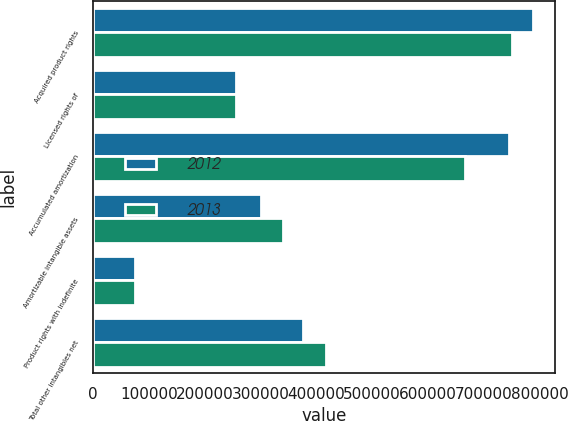Convert chart to OTSL. <chart><loc_0><loc_0><loc_500><loc_500><stacked_bar_chart><ecel><fcel>Acquired product rights<fcel>Licensed rights of<fcel>Accumulated amortization<fcel>Amortizable intangible assets<fcel>Product rights with indefinite<fcel>Total other intangibles net<nl><fcel>2012<fcel>788544<fcel>256555<fcel>744838<fcel>300261<fcel>75738<fcel>375999<nl><fcel>2013<fcel>751016<fcel>256555<fcel>666650<fcel>340921<fcel>75738<fcel>416659<nl></chart> 